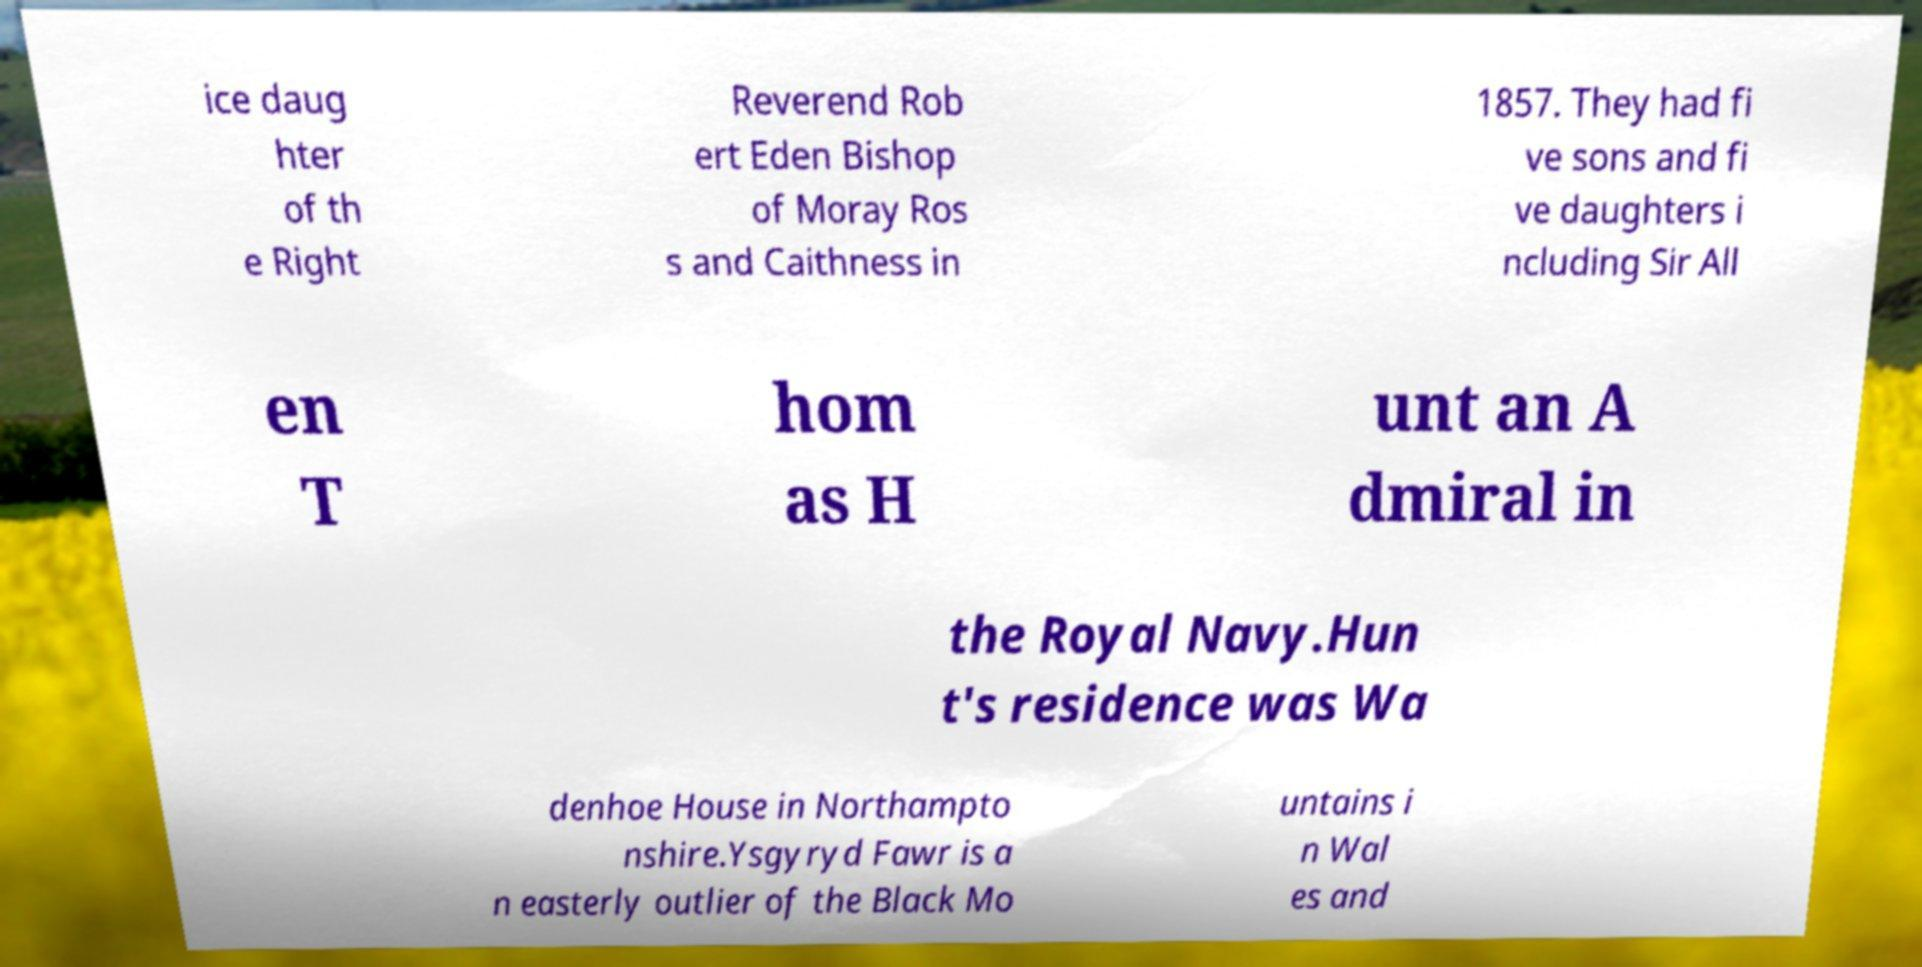What messages or text are displayed in this image? I need them in a readable, typed format. ice daug hter of th e Right Reverend Rob ert Eden Bishop of Moray Ros s and Caithness in 1857. They had fi ve sons and fi ve daughters i ncluding Sir All en T hom as H unt an A dmiral in the Royal Navy.Hun t's residence was Wa denhoe House in Northampto nshire.Ysgyryd Fawr is a n easterly outlier of the Black Mo untains i n Wal es and 